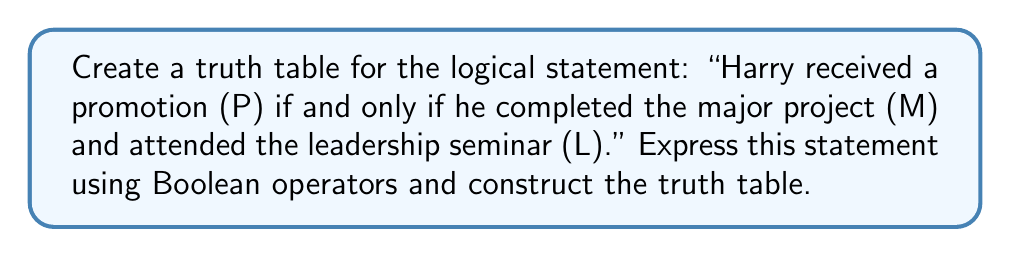Can you solve this math problem? Let's approach this step-by-step:

1) First, we need to express the statement using Boolean operators:
   $P \Leftrightarrow (M \land L)$

2) Now, let's construct the truth table. We have three variables (P, M, L), so our truth table will have $2^3 = 8$ rows.

3) We'll evaluate the expression from left to right:

   $$\begin{array}{|c|c|c|c|c|c|}
   \hline
   P & M & L & M \land L & P \Leftrightarrow (M \land L) \\
   \hline
   0 & 0 & 0 & 0 & 1 \\
   0 & 0 & 1 & 0 & 1 \\
   0 & 1 & 0 & 0 & 1 \\
   0 & 1 & 1 & 1 & 0 \\
   1 & 0 & 0 & 0 & 0 \\
   1 & 0 & 1 & 0 & 0 \\
   1 & 1 & 0 & 0 & 0 \\
   1 & 1 & 1 & 1 & 1 \\
   \hline
   \end{array}$$

4) Explanation of the truth table:
   - The first three columns represent all possible combinations of truth values for P, M, and L.
   - The fourth column ($M \land L$) is true only when both M and L are true.
   - The last column ($P \Leftrightarrow (M \land L)$) is true when P and (M ∧ L) have the same truth value.

5) From the truth table, we can see that the statement is true in four cases:
   - When P, M, and L are all false
   - When P is false, M is false, and L is true
   - When P is false, M is true, and L is false
   - When P, M, and L are all true
Answer: Truth table with 8 rows, 4 true outcomes 